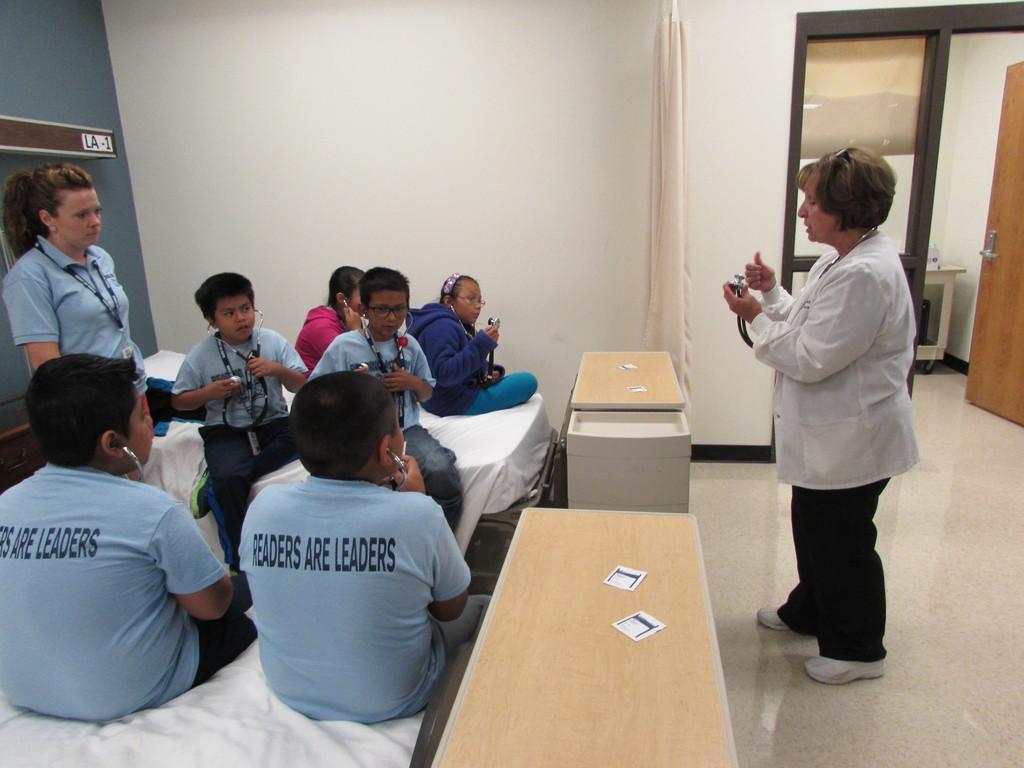Describe this image in one or two sentences. There are some kids sitting on the bed,there are two tables of brown color ,In the right side there is a woman standing and holding something ,In the background there is a door of brown color and a room and white color wall. 